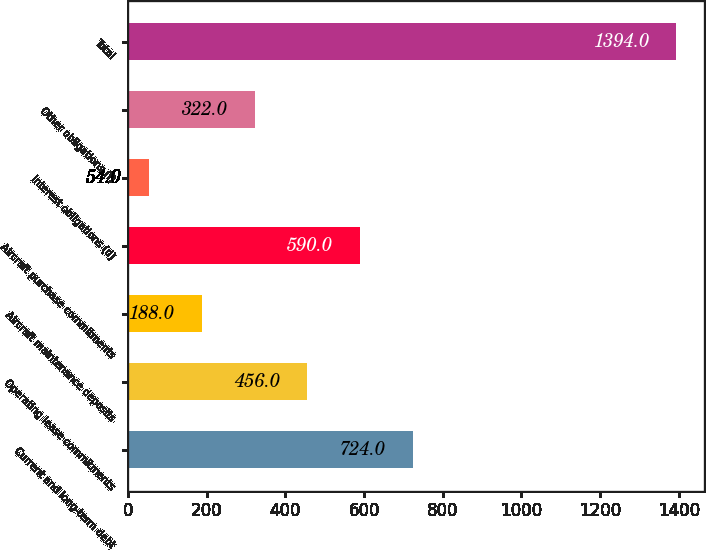Convert chart. <chart><loc_0><loc_0><loc_500><loc_500><bar_chart><fcel>Current and long-term debt<fcel>Operating lease commitments<fcel>Aircraft maintenance deposits<fcel>Aircraft purchase commitments<fcel>Interest obligations (d)<fcel>Other obligations (f)<fcel>Total<nl><fcel>724<fcel>456<fcel>188<fcel>590<fcel>54<fcel>322<fcel>1394<nl></chart> 